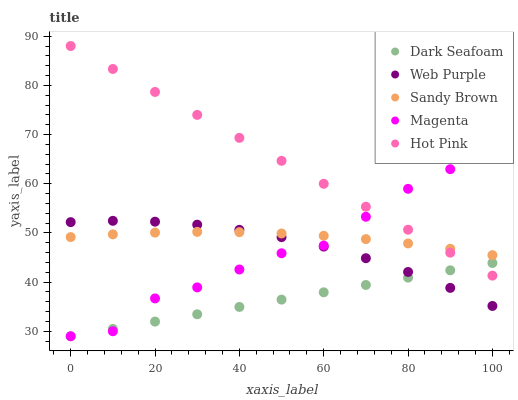Does Dark Seafoam have the minimum area under the curve?
Answer yes or no. Yes. Does Hot Pink have the maximum area under the curve?
Answer yes or no. Yes. Does Sandy Brown have the minimum area under the curve?
Answer yes or no. No. Does Sandy Brown have the maximum area under the curve?
Answer yes or no. No. Is Dark Seafoam the smoothest?
Answer yes or no. Yes. Is Magenta the roughest?
Answer yes or no. Yes. Is Hot Pink the smoothest?
Answer yes or no. No. Is Hot Pink the roughest?
Answer yes or no. No. Does Dark Seafoam have the lowest value?
Answer yes or no. Yes. Does Hot Pink have the lowest value?
Answer yes or no. No. Does Hot Pink have the highest value?
Answer yes or no. Yes. Does Sandy Brown have the highest value?
Answer yes or no. No. Is Web Purple less than Hot Pink?
Answer yes or no. Yes. Is Hot Pink greater than Web Purple?
Answer yes or no. Yes. Does Sandy Brown intersect Magenta?
Answer yes or no. Yes. Is Sandy Brown less than Magenta?
Answer yes or no. No. Is Sandy Brown greater than Magenta?
Answer yes or no. No. Does Web Purple intersect Hot Pink?
Answer yes or no. No. 